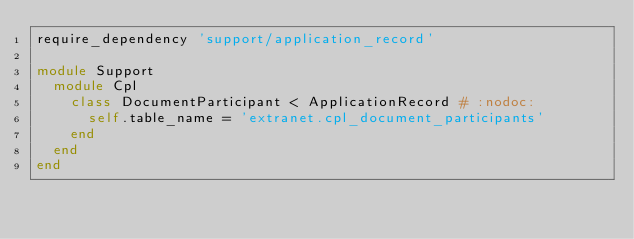<code> <loc_0><loc_0><loc_500><loc_500><_Ruby_>require_dependency 'support/application_record'

module Support
  module Cpl
    class DocumentParticipant < ApplicationRecord # :nodoc:
      self.table_name = 'extranet.cpl_document_participants'
    end
  end
end
</code> 